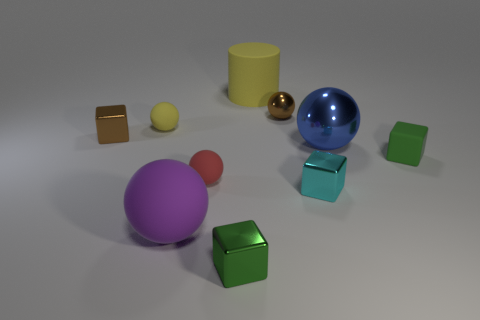Subtract 1 spheres. How many spheres are left? 4 Subtract all purple spheres. How many spheres are left? 4 Subtract all small brown spheres. How many spheres are left? 4 Subtract all cyan balls. Subtract all brown blocks. How many balls are left? 5 Subtract all cubes. How many objects are left? 6 Add 6 big yellow objects. How many big yellow objects are left? 7 Add 6 yellow shiny things. How many yellow shiny things exist? 6 Subtract 1 yellow balls. How many objects are left? 9 Subtract all blue shiny balls. Subtract all large cylinders. How many objects are left? 8 